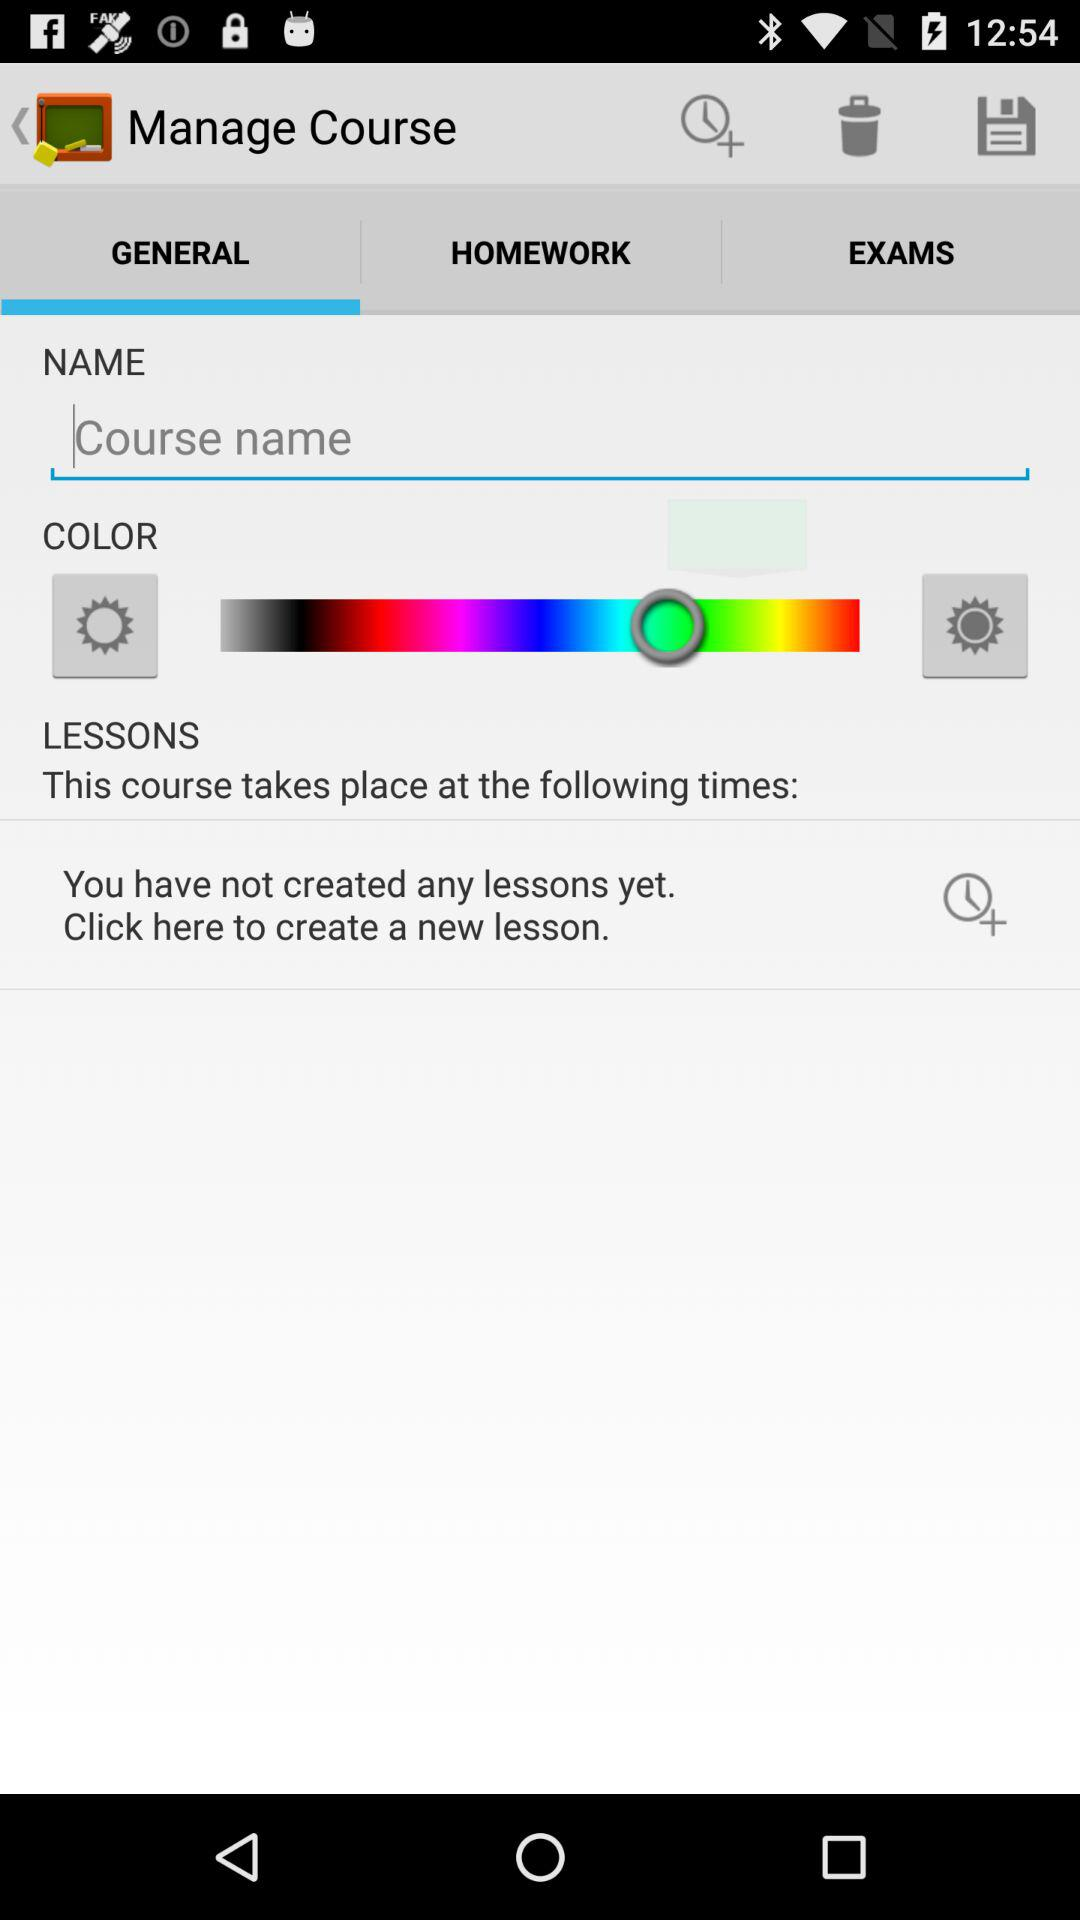Which option is selected? The selected option is "GENERAL". 